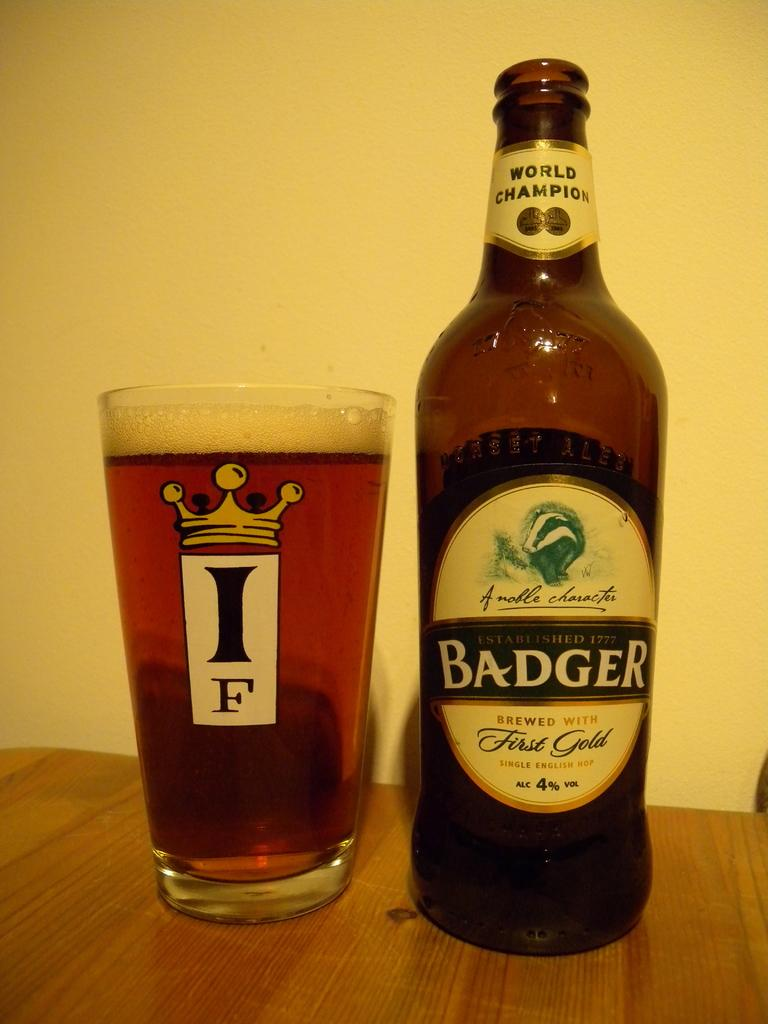<image>
Offer a succinct explanation of the picture presented. A bottle, labelled Badger, stands next to a full glass with the letters "IF" on it. 